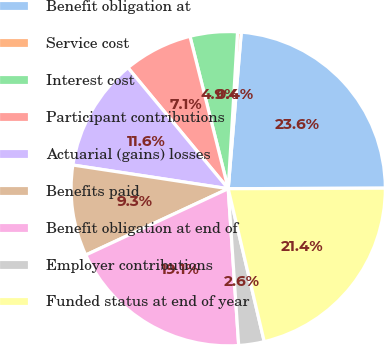Convert chart to OTSL. <chart><loc_0><loc_0><loc_500><loc_500><pie_chart><fcel>Benefit obligation at<fcel>Service cost<fcel>Interest cost<fcel>Participant contributions<fcel>Actuarial (gains) losses<fcel>Benefits paid<fcel>Benefit obligation at end of<fcel>Employer contributions<fcel>Funded status at end of year<nl><fcel>23.62%<fcel>0.38%<fcel>4.86%<fcel>7.1%<fcel>11.58%<fcel>9.34%<fcel>19.13%<fcel>2.62%<fcel>21.37%<nl></chart> 